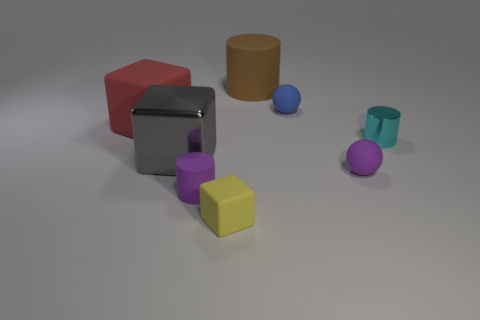Subtract 1 blocks. How many blocks are left? 2 Subtract all rubber blocks. How many blocks are left? 1 Add 2 big yellow metal cylinders. How many objects exist? 10 Subtract all balls. How many objects are left? 6 Subtract all purple blocks. Subtract all purple spheres. How many blocks are left? 3 Subtract 0 yellow spheres. How many objects are left? 8 Subtract all big purple rubber cylinders. Subtract all tiny purple things. How many objects are left? 6 Add 7 spheres. How many spheres are left? 9 Add 3 metal things. How many metal things exist? 5 